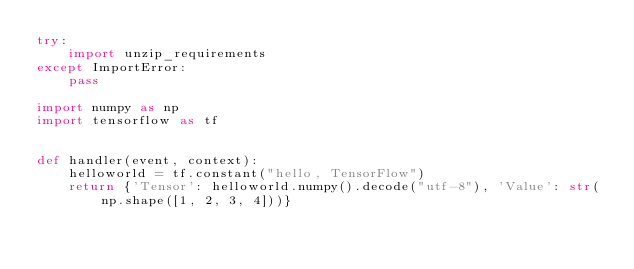<code> <loc_0><loc_0><loc_500><loc_500><_Python_>try:
    import unzip_requirements
except ImportError:
    pass

import numpy as np
import tensorflow as tf


def handler(event, context):
    helloworld = tf.constant("hello, TensorFlow")
    return {'Tensor': helloworld.numpy().decode("utf-8"), 'Value': str(np.shape([1, 2, 3, 4]))}
</code> 